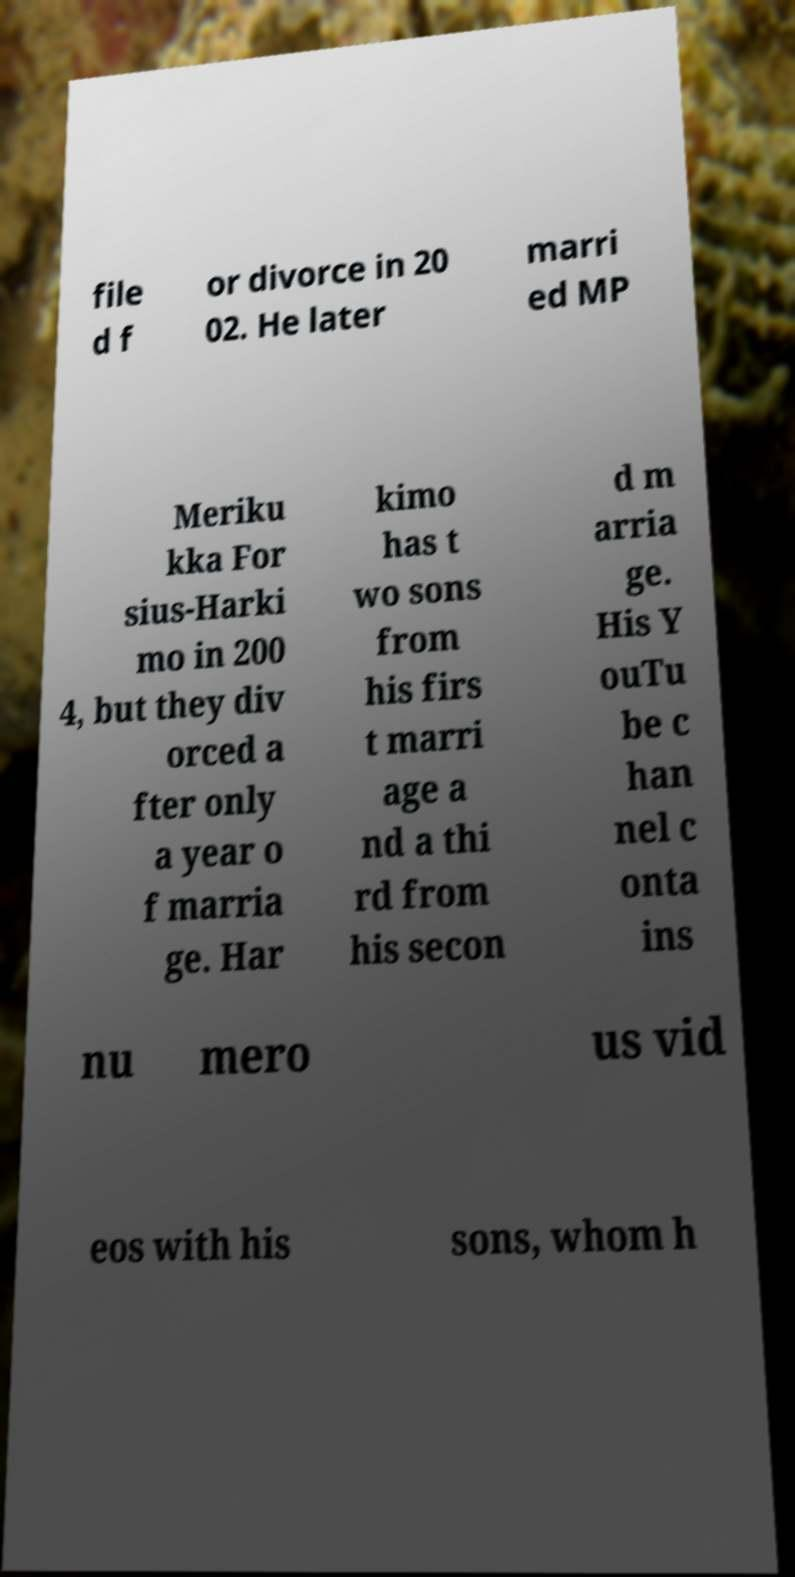Please read and relay the text visible in this image. What does it say? file d f or divorce in 20 02. He later marri ed MP Meriku kka For sius-Harki mo in 200 4, but they div orced a fter only a year o f marria ge. Har kimo has t wo sons from his firs t marri age a nd a thi rd from his secon d m arria ge. His Y ouTu be c han nel c onta ins nu mero us vid eos with his sons, whom h 